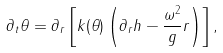<formula> <loc_0><loc_0><loc_500><loc_500>\partial _ { t } \theta = \partial _ { r } \left [ k ( \theta ) \left ( \partial _ { r } h - \frac { \omega ^ { 2 } } { g } r \right ) \right ] ,</formula> 